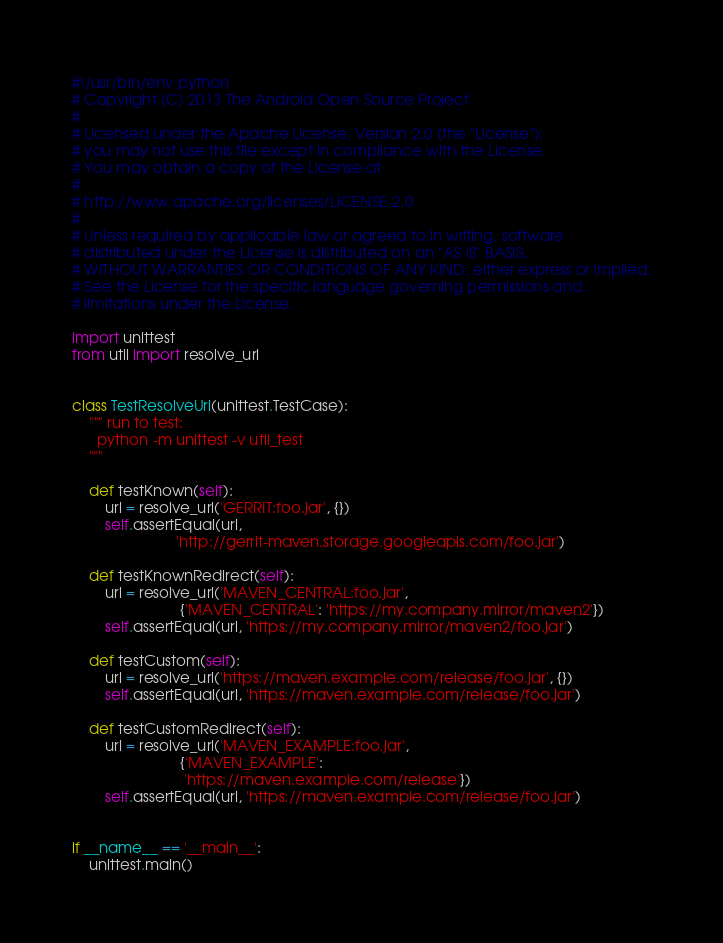<code> <loc_0><loc_0><loc_500><loc_500><_Python_>#!/usr/bin/env python
# Copyright (C) 2013 The Android Open Source Project
#
# Licensed under the Apache License, Version 2.0 (the "License");
# you may not use this file except in compliance with the License.
# You may obtain a copy of the License at
#
# http://www.apache.org/licenses/LICENSE-2.0
#
# Unless required by applicable law or agreed to in writing, software
# distributed under the License is distributed on an "AS IS" BASIS,
# WITHOUT WARRANTIES OR CONDITIONS OF ANY KIND, either express or implied.
# See the License for the specific language governing permissions and
# limitations under the License.

import unittest
from util import resolve_url


class TestResolveUrl(unittest.TestCase):
    """ run to test:
      python -m unittest -v util_test
    """

    def testKnown(self):
        url = resolve_url('GERRIT:foo.jar', {})
        self.assertEqual(url,
                         'http://gerrit-maven.storage.googleapis.com/foo.jar')

    def testKnownRedirect(self):
        url = resolve_url('MAVEN_CENTRAL:foo.jar',
                          {'MAVEN_CENTRAL': 'https://my.company.mirror/maven2'})
        self.assertEqual(url, 'https://my.company.mirror/maven2/foo.jar')

    def testCustom(self):
        url = resolve_url('https://maven.example.com/release/foo.jar', {})
        self.assertEqual(url, 'https://maven.example.com/release/foo.jar')

    def testCustomRedirect(self):
        url = resolve_url('MAVEN_EXAMPLE:foo.jar',
                          {'MAVEN_EXAMPLE':
                           'https://maven.example.com/release'})
        self.assertEqual(url, 'https://maven.example.com/release/foo.jar')


if __name__ == '__main__':
    unittest.main()
</code> 